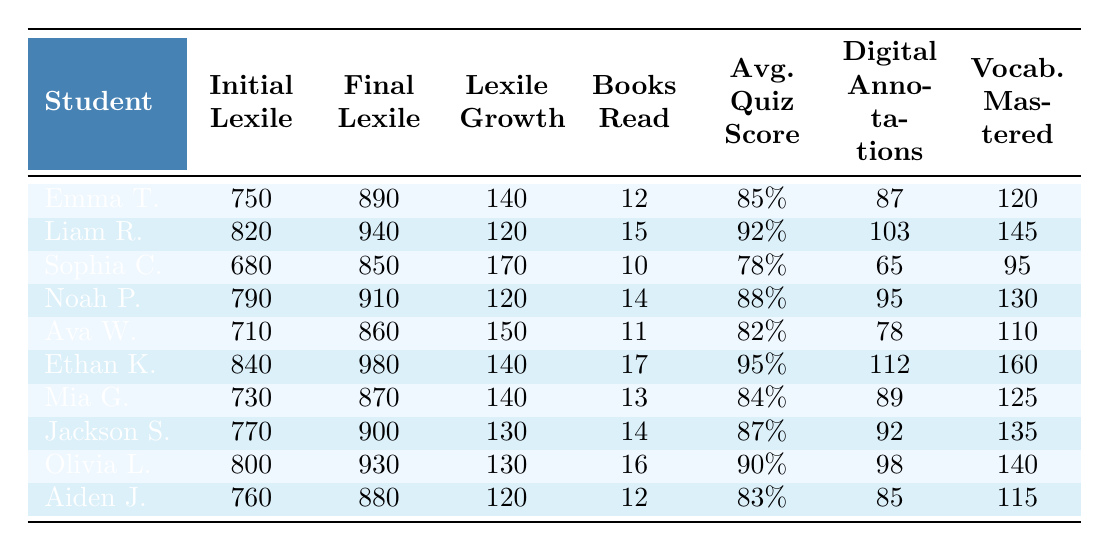What is the highest final lexile score among the students? By reviewing the final lexile scores of all students, Ethan Kim has the highest score at 980.
Answer: 980 How many books did Sophia Chen read? Sophia read a total of 10 books, which is directly stated in the table.
Answer: 10 What was the average quiz score of Liam Rodriguez? Liam's average quiz score is 92%, which is listed in the table.
Answer: 92% Which student had the lowest initial lexile score? Upon inspection, Sophia Chen had the lowest initial lexile score of 680.
Answer: 680 What is the lexile growth of Mia Gonzalez? Mia’s final lexile score is 870, and her initial score was 730. The growth is calculated as 870 - 730 = 140.
Answer: 140 Did Ethan Kim read more books than Noah Patel? Ethan read 17 books while Noah read 14 books; thus, he did read more books.
Answer: Yes What is the total number of books read by all students? The total is found by summing the books read: 12 + 15 + 10 + 14 + 11 + 17 + 13 + 14 + 16 + 12 =  140.
Answer: 140 Which student mastered the most vocabulary flashcards? Based on the table, Ethan Kim mastered the most flashcards, totaling 160.
Answer: 160 What is the average final lexile score across all students? To find the average, we sum the final lexile scores (890 + 940 + 850 + 910 + 860 + 980 + 870 + 900 + 930 + 880 =  8830) and divide by the number of students (10): 8830 / 10 = 883.
Answer: 883 Is there any student who had a lexile growth greater than 150? Yes, both Sophia Chen (170) and Ava Washington (150) had lexile growth greater than 150.
Answer: Yes 